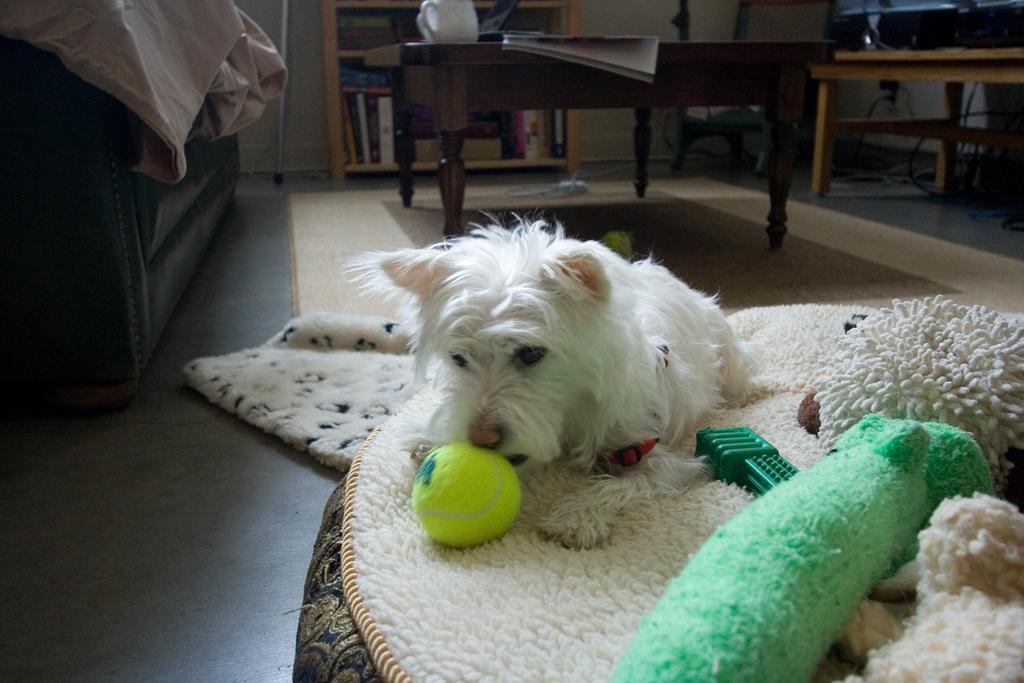Describe this image in one or two sentences. This is a small dog sitting on the cushion. This is a tennis ball and some toys. This looks like a couch. This is a teapoy with a jug and book on it. At background I can see some books placed in the bookshelf. 